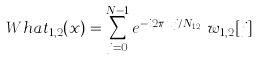<formula> <loc_0><loc_0><loc_500><loc_500>\ W h a t _ { 1 , 2 } ( x ) = \sum _ { j = 0 } ^ { N - 1 } e ^ { - i 2 \pi x j / N _ { 1 , 2 } } \, w _ { 1 , 2 } [ j ]</formula> 